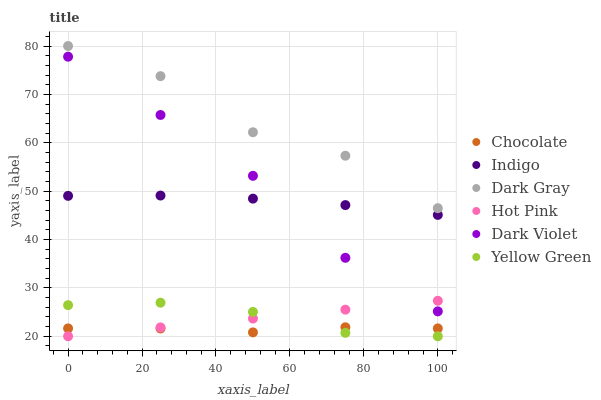Does Chocolate have the minimum area under the curve?
Answer yes or no. Yes. Does Dark Gray have the maximum area under the curve?
Answer yes or no. Yes. Does Yellow Green have the minimum area under the curve?
Answer yes or no. No. Does Yellow Green have the maximum area under the curve?
Answer yes or no. No. Is Hot Pink the smoothest?
Answer yes or no. Yes. Is Dark Gray the roughest?
Answer yes or no. Yes. Is Yellow Green the smoothest?
Answer yes or no. No. Is Yellow Green the roughest?
Answer yes or no. No. Does Yellow Green have the lowest value?
Answer yes or no. Yes. Does Dark Violet have the lowest value?
Answer yes or no. No. Does Dark Gray have the highest value?
Answer yes or no. Yes. Does Yellow Green have the highest value?
Answer yes or no. No. Is Yellow Green less than Dark Gray?
Answer yes or no. Yes. Is Dark Violet greater than Chocolate?
Answer yes or no. Yes. Does Yellow Green intersect Hot Pink?
Answer yes or no. Yes. Is Yellow Green less than Hot Pink?
Answer yes or no. No. Is Yellow Green greater than Hot Pink?
Answer yes or no. No. Does Yellow Green intersect Dark Gray?
Answer yes or no. No. 